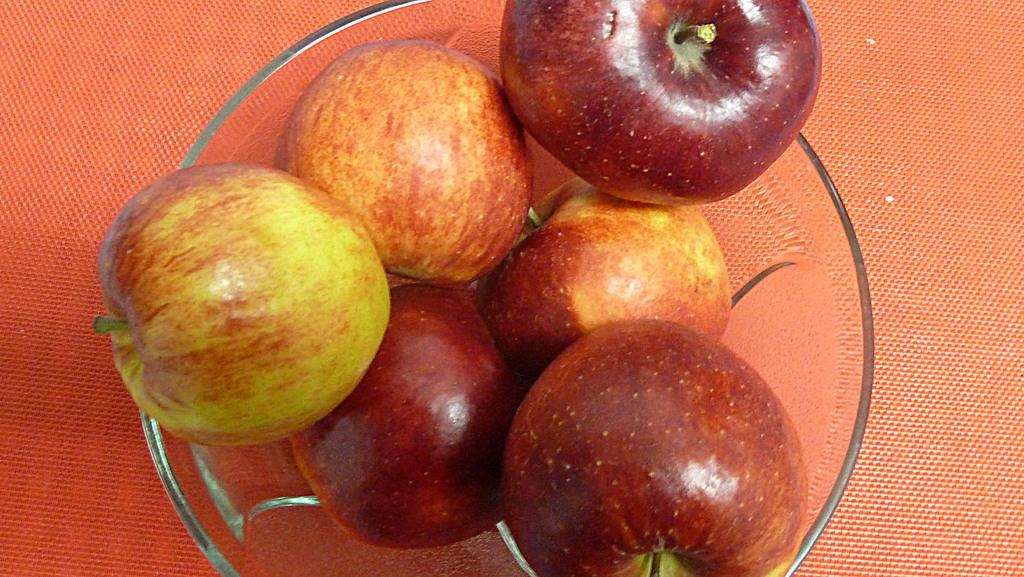What type of fruit is present in the image? There are apples in the image. Where are the apples located? The apples are in a bowl. On what surface is the bowl placed? The bowl is placed on a table. What type of fowl is sitting on the table next to the apples? There is no fowl present in the image; it only features apples in a bowl on a table. 